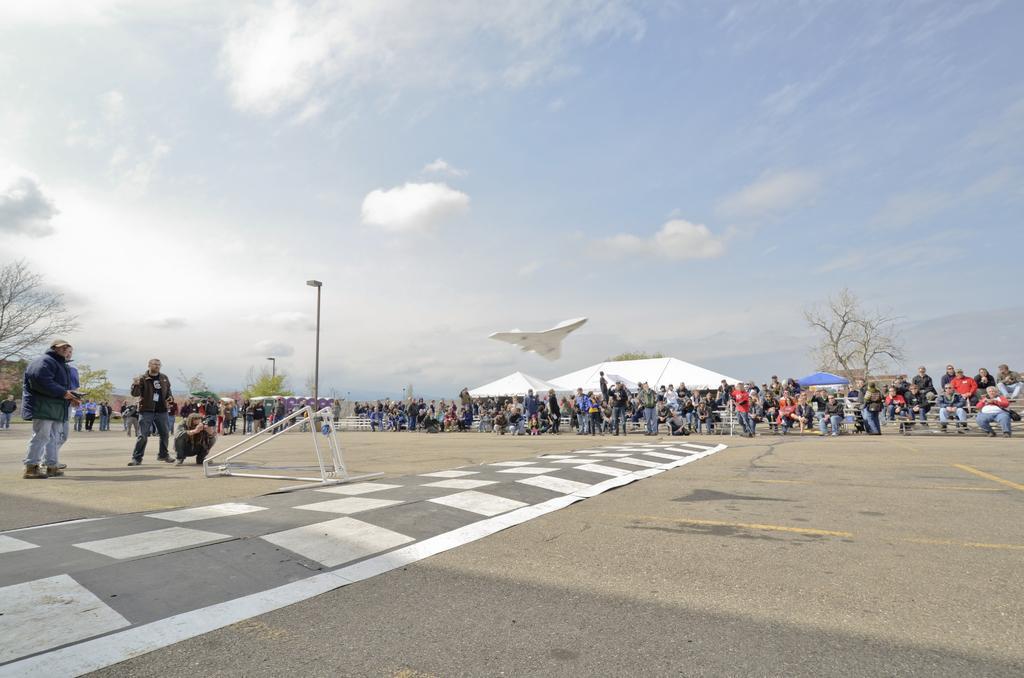Describe this image in one or two sentences. In this image we can see metal frame, aircraft, sheds, trees, street light, sky and we can also see people standing on the road. 